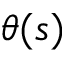Convert formula to latex. <formula><loc_0><loc_0><loc_500><loc_500>\theta ( s )</formula> 